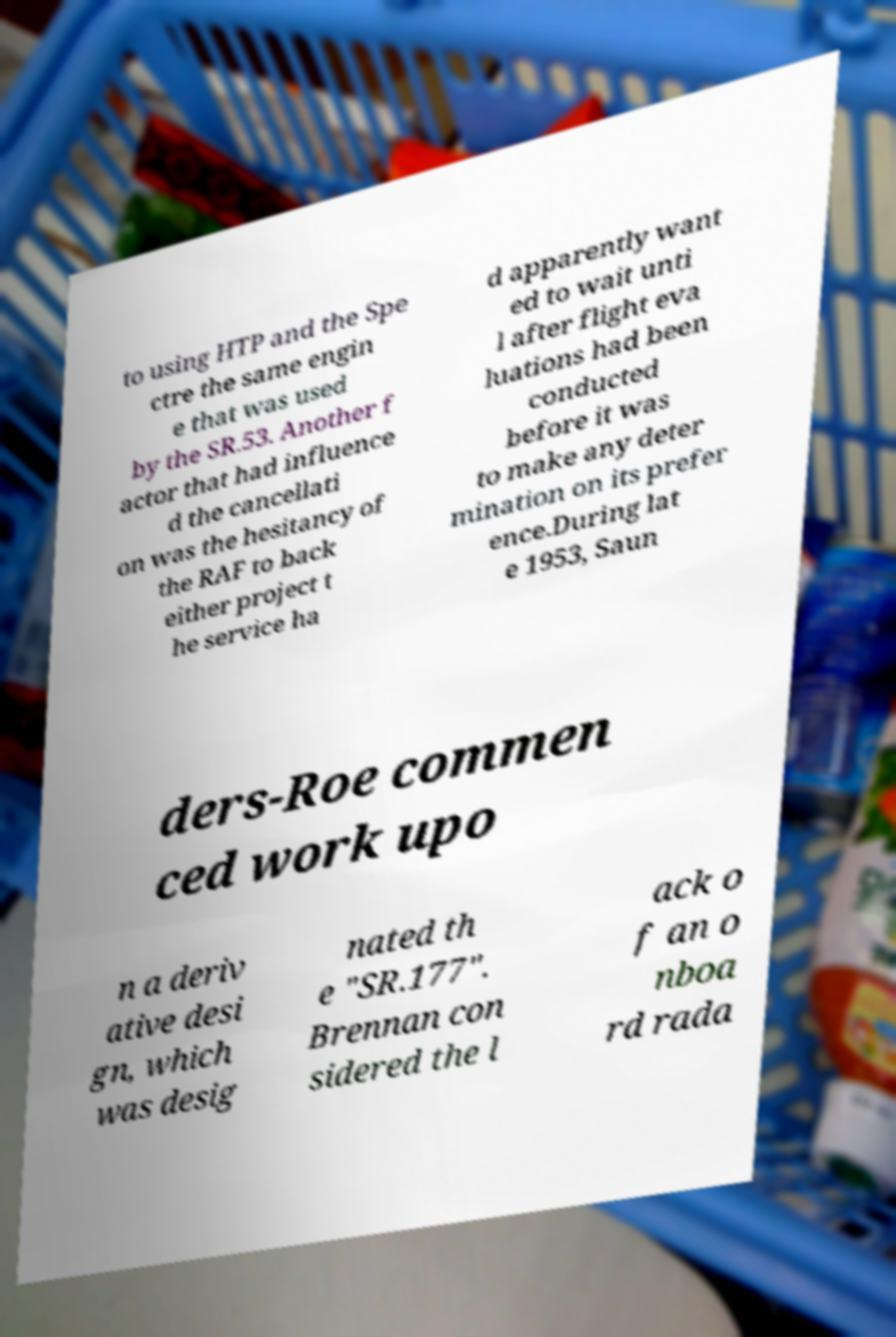I need the written content from this picture converted into text. Can you do that? to using HTP and the Spe ctre the same engin e that was used by the SR.53. Another f actor that had influence d the cancellati on was the hesitancy of the RAF to back either project t he service ha d apparently want ed to wait unti l after flight eva luations had been conducted before it was to make any deter mination on its prefer ence.During lat e 1953, Saun ders-Roe commen ced work upo n a deriv ative desi gn, which was desig nated th e "SR.177". Brennan con sidered the l ack o f an o nboa rd rada 